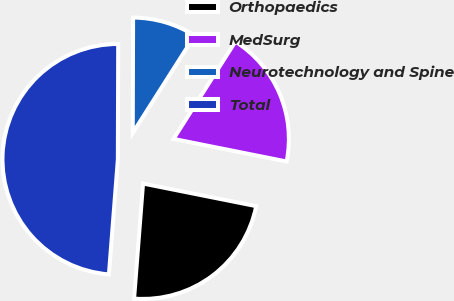<chart> <loc_0><loc_0><loc_500><loc_500><pie_chart><fcel>Orthopaedics<fcel>MedSurg<fcel>Neurotechnology and Spine<fcel>Total<nl><fcel>23.1%<fcel>19.12%<fcel>8.97%<fcel>48.81%<nl></chart> 